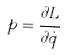Convert formula to latex. <formula><loc_0><loc_0><loc_500><loc_500>p = \frac { \partial L } { \partial \dot { q } }</formula> 